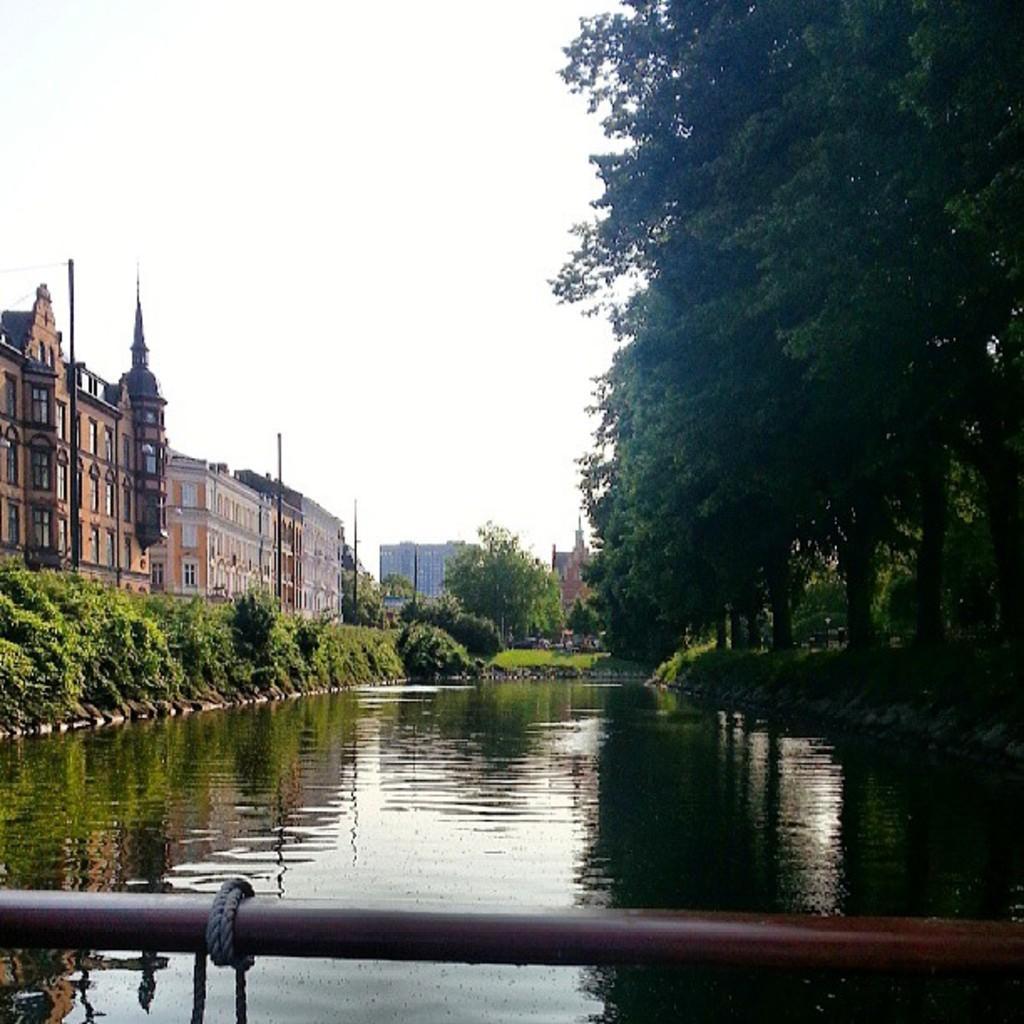Describe this image in one or two sentences. This is water and there are trees. In the background we can see buildings, poles, and sky. 